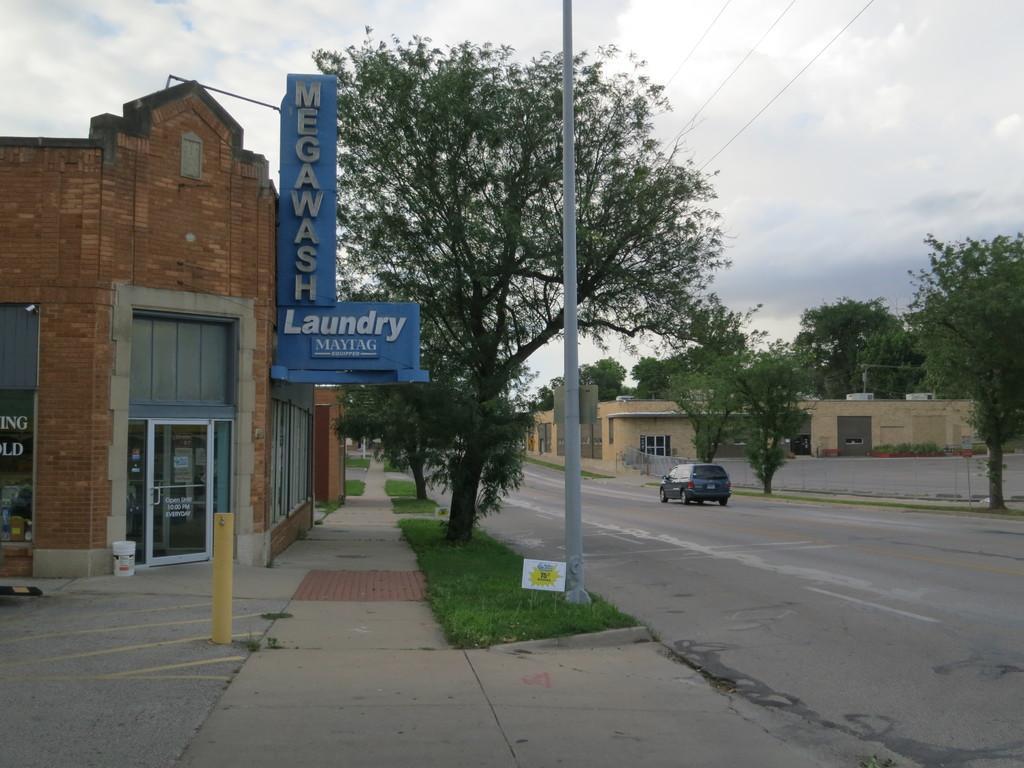Could you give a brief overview of what you see in this image? In the middle of the image we can see some trees, poles and buildings. At the top of the image we can see some clouds in the sky. In the bottom right corner of the image we can see a vehicle on the road. 